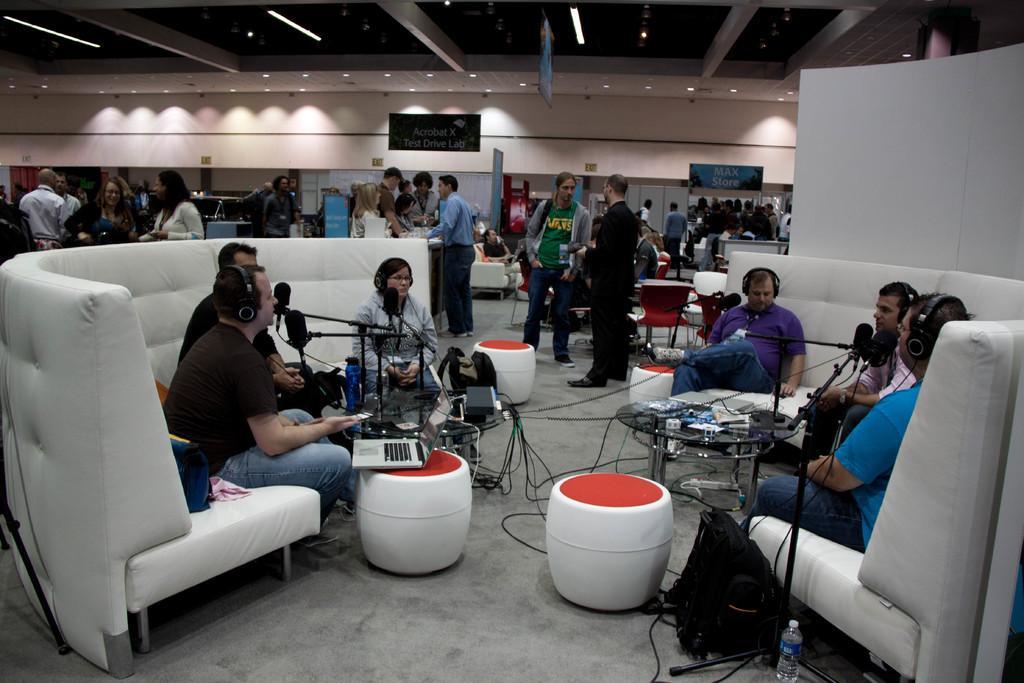Could you give a brief overview of what you see in this image? A group of people are sitting in the couch and have a laptop, microphone stand in front of them and there are some people standing in the backdrop. 